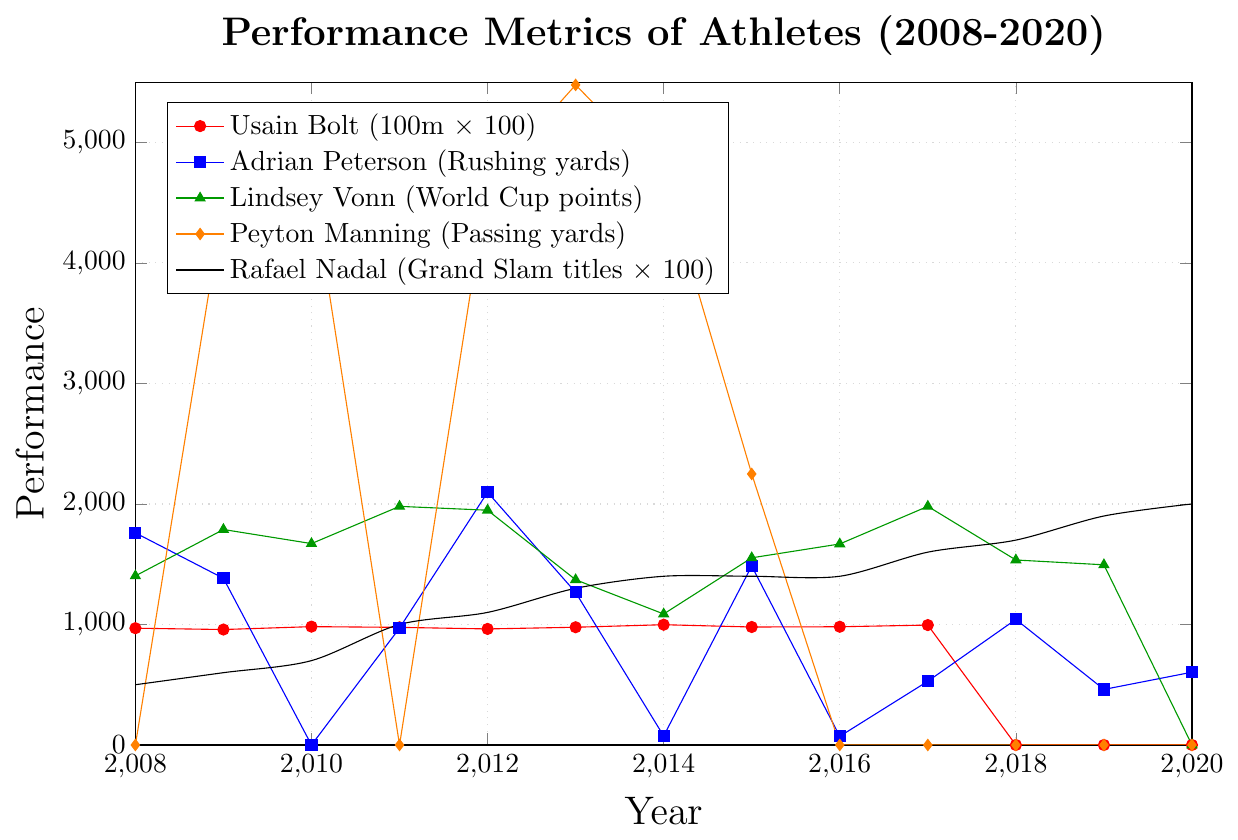What year did Usain Bolt's 100m sprint performance start to decline significantly? Usain Bolt's performance in the 100m sprint began to decline significantly after 2012, as evidenced by the increase in his times from 9.77 in 2013 to 9.98 in 2014.
Answer: 2013 Which athlete has the most frequent zero performance values? Peyton Manning has the most frequent zero performance values, especially evident from 2016 to 2020.
Answer: Peyton Manning How many Grand Slam titles did Rafael Nadal win between 2008 and 2010? Rafael Nadal's Grand Slam titles are represented by the Y-axis value divided by 100. Therefore, between 2008 (500) and 2010 (700), the number of titles won is (700/100) - (500/100) = 7 - 5 = 2.
Answer: 2 Compare the highest performance value of Peyton Manning to that of Adrian Peterson. Peyton Manning's highest performance value is 5477 in 2013, and Adrian Peterson's highest performance is 2097 in 2012. 5477 is greater than 2097.
Answer: Peyton Manning Which athlete has a generally increasing performance metric? Rafael Nadal shows a generally increasing performance metric from 2008 to 2020.
Answer: Rafael Nadal What year did Lindsey Vonn reach her peak performance according to the chart? Lindsey Vonn reached her peak performance in 2011 with a value of 1980.
Answer: 2011 What is the average rushing yards for Adrian Peterson from 2008 to 2020? Sum of Adrian Peterson's rushing yards from 2008 to 2020: 1760 + 1383 + 0 + 970 + 2097 + 1266 + 75 + 1485 + 72 + 529 + 1042 + 461 + 604 = 11744. Average = 11744 / 13 = 903.38
Answer: 903.38 Which year did Adrian Peterson have his lowest performance, and what was the value? Adrian Peterson had his lowest performance in 2016 with a value of 72.
Answer: 2016 For which athlete does the performance data end before 2020? Usain Bolt's performance data ends after 2017.
Answer: Usain Bolt What is the difference in Lindsey Vonn's World Cup points between 2015 and 2017? In 2015, Lindsey Vonn's points were 1553, and in 2017, her points were 1980. The difference is 1980 - 1553 = 427.
Answer: 427 